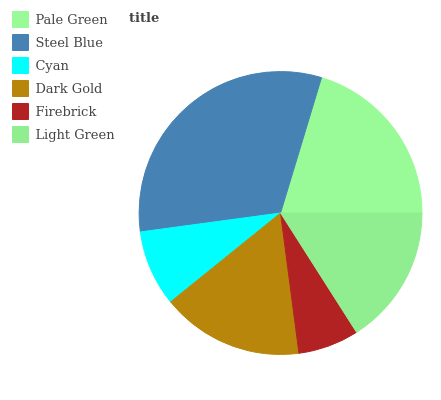Is Firebrick the minimum?
Answer yes or no. Yes. Is Steel Blue the maximum?
Answer yes or no. Yes. Is Cyan the minimum?
Answer yes or no. No. Is Cyan the maximum?
Answer yes or no. No. Is Steel Blue greater than Cyan?
Answer yes or no. Yes. Is Cyan less than Steel Blue?
Answer yes or no. Yes. Is Cyan greater than Steel Blue?
Answer yes or no. No. Is Steel Blue less than Cyan?
Answer yes or no. No. Is Dark Gold the high median?
Answer yes or no. Yes. Is Light Green the low median?
Answer yes or no. Yes. Is Cyan the high median?
Answer yes or no. No. Is Dark Gold the low median?
Answer yes or no. No. 